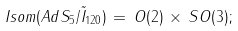Convert formula to latex. <formula><loc_0><loc_0><loc_500><loc_500>I s o m ( A d S _ { 5 } / \tilde { I } _ { 1 2 0 } ) \, = \, O ( 2 ) \, \times \, S O ( 3 ) ;</formula> 